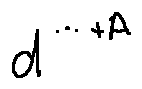<formula> <loc_0><loc_0><loc_500><loc_500>d ^ { \cdots + A }</formula> 